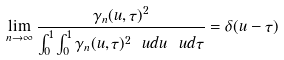<formula> <loc_0><loc_0><loc_500><loc_500>\lim _ { n \to \infty } \frac { \gamma _ { n } ( u , \tau ) ^ { 2 } } { \int _ { 0 } ^ { 1 } \int _ { 0 } ^ { 1 } \gamma _ { n } ( u , \tau ) ^ { 2 } \ u d u \ u d \tau } = \delta ( u - \tau )</formula> 